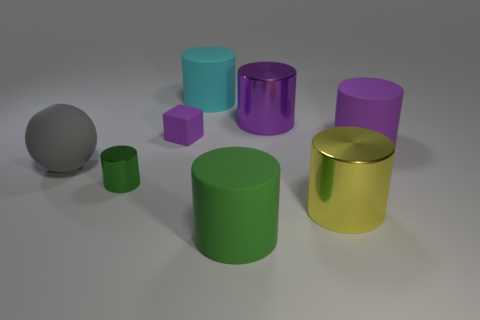How many brown objects are either large metallic objects or rubber balls?
Make the answer very short. 0. Is the size of the cyan cylinder the same as the metal cylinder that is behind the gray matte thing?
Your answer should be very brief. Yes. There is a small green thing that is the same shape as the yellow metallic thing; what is it made of?
Ensure brevity in your answer.  Metal. How many other objects are there of the same size as the gray thing?
Keep it short and to the point. 5. There is a purple object on the right side of the metallic cylinder behind the matte object on the left side of the tiny rubber cube; what shape is it?
Keep it short and to the point. Cylinder. What shape is the object that is to the left of the tiny matte thing and behind the tiny green metallic cylinder?
Offer a very short reply. Sphere. What number of objects are either large yellow metallic cylinders or big objects in front of the tiny green metal thing?
Offer a terse response. 2. Are the cyan cylinder and the block made of the same material?
Keep it short and to the point. Yes. What number of other objects are there of the same shape as the big yellow object?
Give a very brief answer. 5. What is the size of the cylinder that is both left of the big yellow shiny object and in front of the tiny metallic object?
Your answer should be compact. Large. 